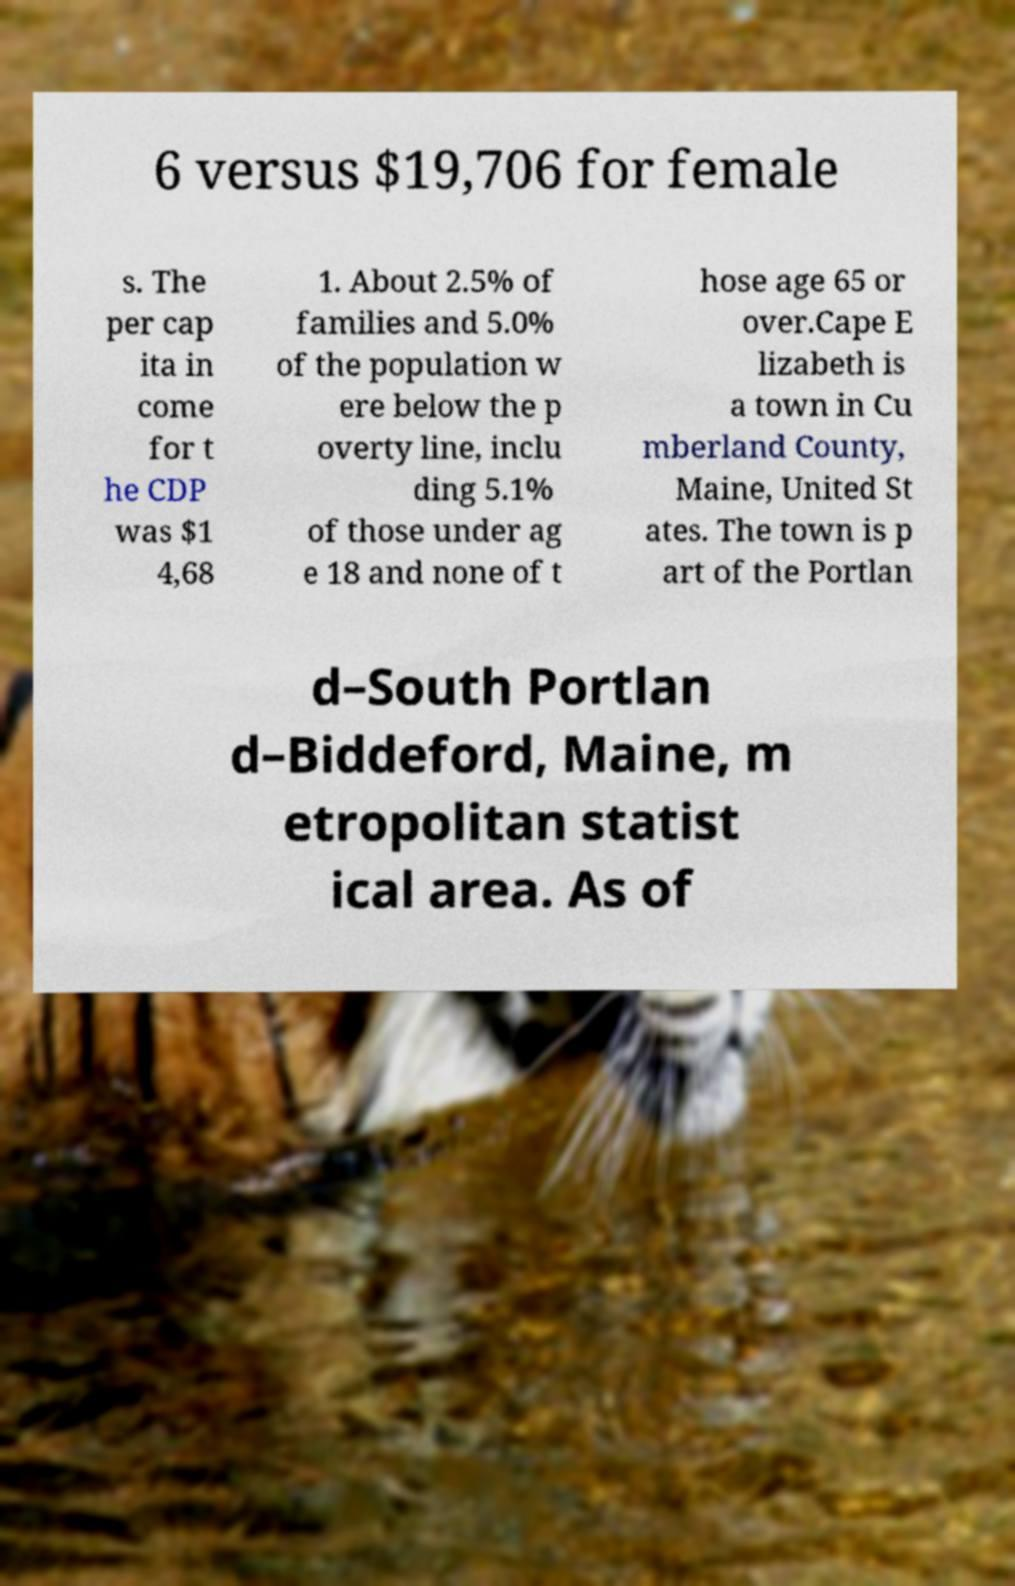What messages or text are displayed in this image? I need them in a readable, typed format. 6 versus $19,706 for female s. The per cap ita in come for t he CDP was $1 4,68 1. About 2.5% of families and 5.0% of the population w ere below the p overty line, inclu ding 5.1% of those under ag e 18 and none of t hose age 65 or over.Cape E lizabeth is a town in Cu mberland County, Maine, United St ates. The town is p art of the Portlan d–South Portlan d–Biddeford, Maine, m etropolitan statist ical area. As of 